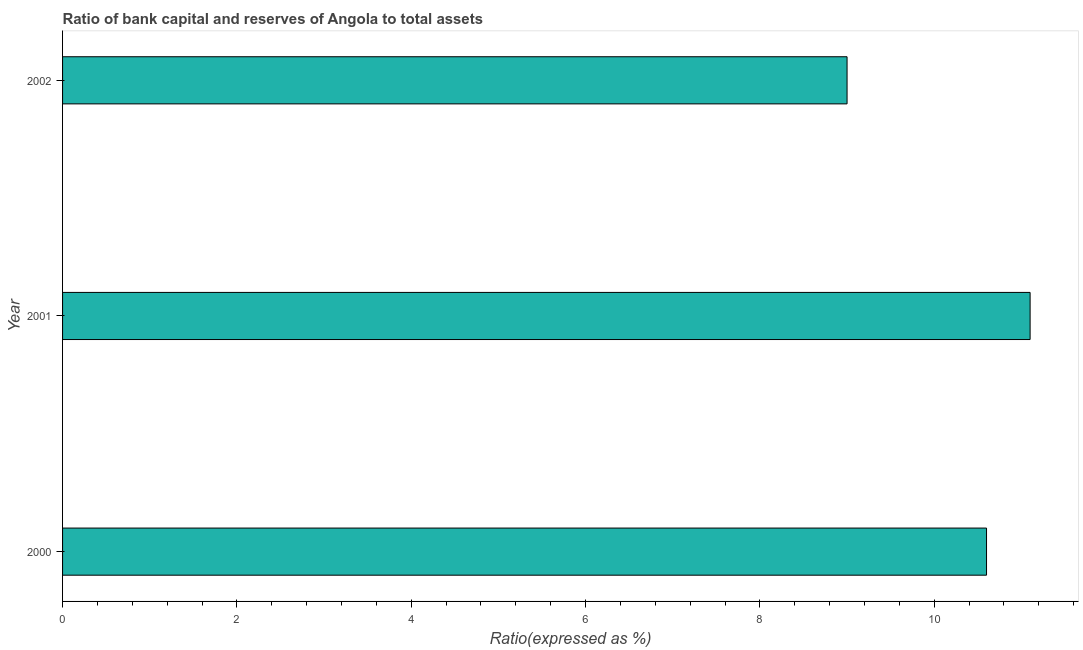Does the graph contain any zero values?
Ensure brevity in your answer.  No. What is the title of the graph?
Provide a short and direct response. Ratio of bank capital and reserves of Angola to total assets. What is the label or title of the X-axis?
Keep it short and to the point. Ratio(expressed as %). What is the label or title of the Y-axis?
Provide a short and direct response. Year. In which year was the bank capital to assets ratio minimum?
Your answer should be compact. 2002. What is the sum of the bank capital to assets ratio?
Provide a short and direct response. 30.7. What is the difference between the bank capital to assets ratio in 2000 and 2001?
Provide a succinct answer. -0.5. What is the average bank capital to assets ratio per year?
Offer a terse response. 10.23. What is the median bank capital to assets ratio?
Offer a terse response. 10.6. In how many years, is the bank capital to assets ratio greater than 7.6 %?
Your response must be concise. 3. Do a majority of the years between 2002 and 2000 (inclusive) have bank capital to assets ratio greater than 6 %?
Provide a short and direct response. Yes. What is the ratio of the bank capital to assets ratio in 2000 to that in 2002?
Your answer should be compact. 1.18. In how many years, is the bank capital to assets ratio greater than the average bank capital to assets ratio taken over all years?
Ensure brevity in your answer.  2. How many bars are there?
Offer a terse response. 3. Are all the bars in the graph horizontal?
Give a very brief answer. Yes. What is the Ratio(expressed as %) in 2000?
Provide a short and direct response. 10.6. What is the Ratio(expressed as %) in 2001?
Keep it short and to the point. 11.1. What is the Ratio(expressed as %) of 2002?
Make the answer very short. 9. What is the difference between the Ratio(expressed as %) in 2000 and 2001?
Offer a terse response. -0.5. What is the difference between the Ratio(expressed as %) in 2001 and 2002?
Your response must be concise. 2.1. What is the ratio of the Ratio(expressed as %) in 2000 to that in 2001?
Ensure brevity in your answer.  0.95. What is the ratio of the Ratio(expressed as %) in 2000 to that in 2002?
Offer a terse response. 1.18. What is the ratio of the Ratio(expressed as %) in 2001 to that in 2002?
Provide a succinct answer. 1.23. 